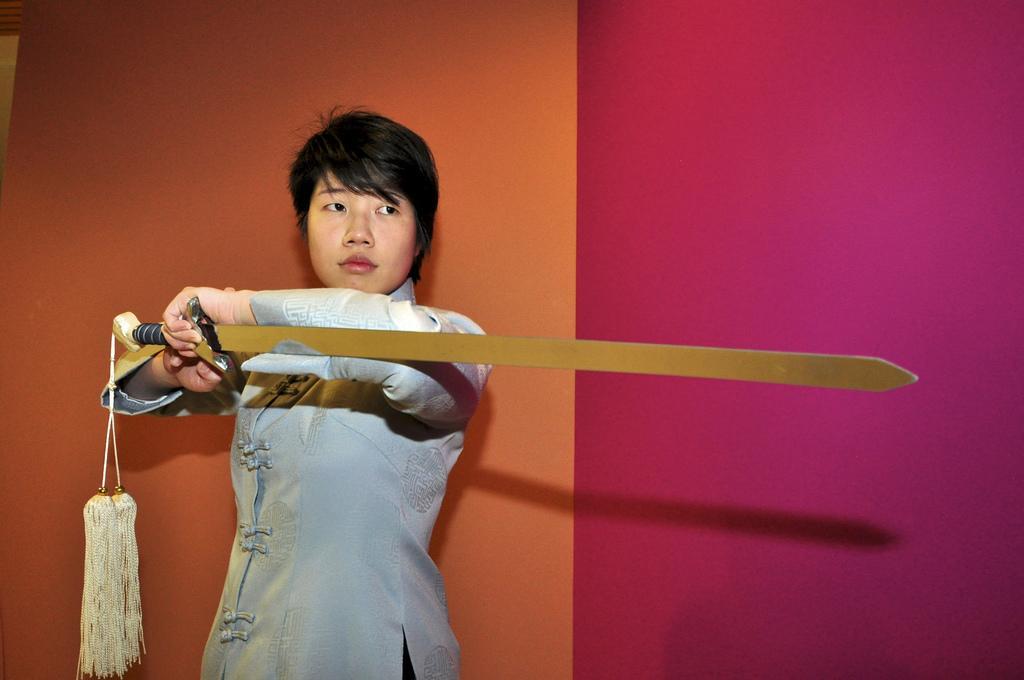In one or two sentences, can you explain what this image depicts? In the center of the image we can see a person is holding a sword. In the background of the image we can see the wall. 